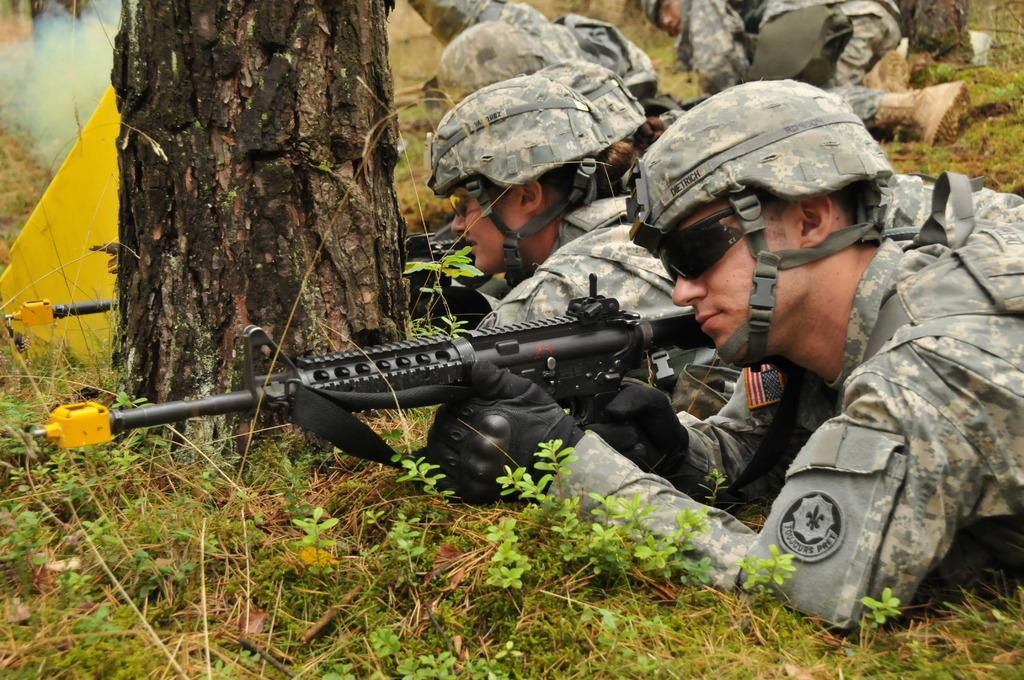What type of people can be seen in the image? There are army people in the image. What are the army people doing in the image? The army people are laying on the grass in the image. What are the army people holding in the image? The army people are holding guns in the image. What natural element can be seen in the image? There is a stem of a tree in the image. What type of dogs can be seen playing in the sleet in the image? There are no dogs or sleet present in the image; it features army people laying on the grass and holding guns. 